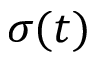Convert formula to latex. <formula><loc_0><loc_0><loc_500><loc_500>\sigma ( t )</formula> 